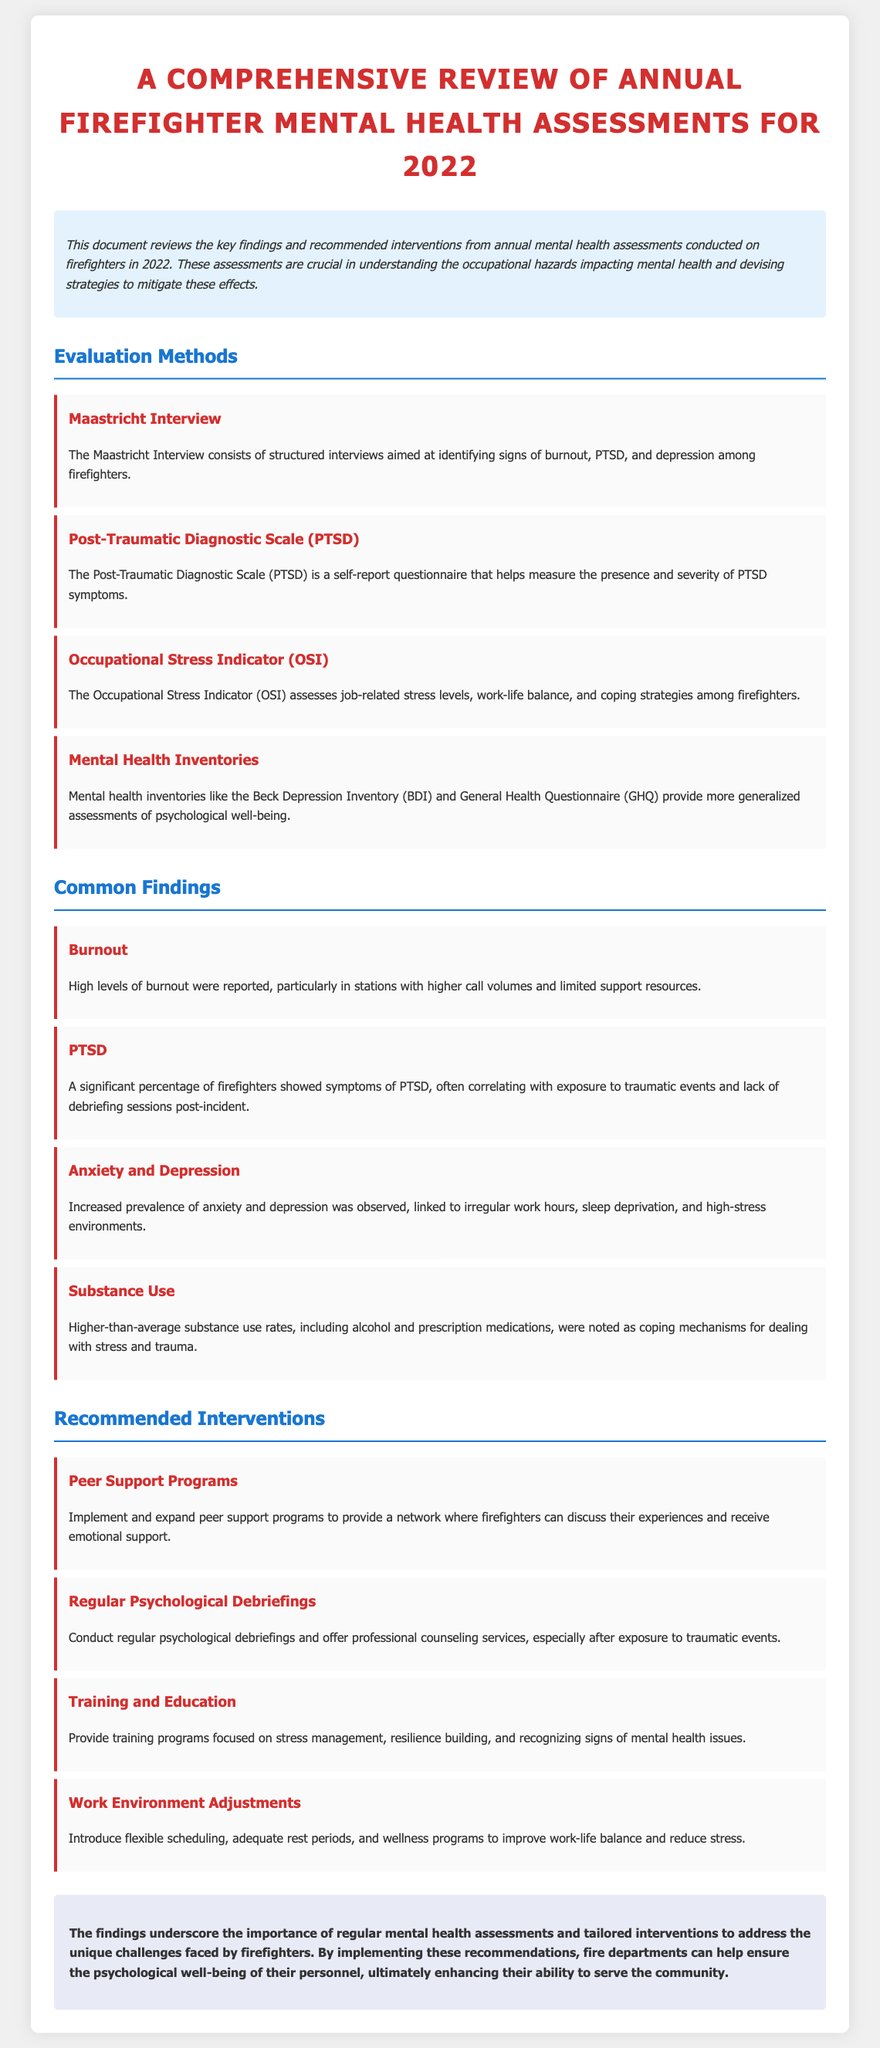What is the title of the document? The title of the document is clearly mentioned at the top and states the focus of the review.
Answer: A Comprehensive Review of Annual Firefighter Mental Health Assessments for 2022 What method is used to assess PTSD symptoms? The document specifies the name of the self-report questionnaire used to measure PTSD symptoms among firefighters.
Answer: Post-Traumatic Diagnostic Scale (PTSD) Which occupational stress indicator assesses work-life balance? The section on evaluation methods identifies the specific tool used to evaluate job-related stress levels, including work-life balance.
Answer: Occupational Stress Indicator (OSI) What is a common finding related to substance use? The document reveals a significant trend regarding coping mechanisms used by firefighters to deal with stress.
Answer: Higher-than-average substance use rates What intervention is recommended for peer support? The recommendations section outlines specific programs aimed at providing emotional support among firefighters.
Answer: Peer Support Programs How is burnout related to call volumes? The findings draw a connection between burnout levels and operational challenges within the firefighters' work environment.
Answer: Higher call volumes and limited support resources How many assessment methods are listed in the document? By counting the methods outlined under the evaluation methods section, the total can be determined.
Answer: Four What is a key conclusion of the review? The conclusion summarizes the importance of addressing mental health issues based on the findings from the assessments.
Answer: Regular mental health assessments and tailored interventions What does the document suggest for work environment adjustments? The document recommends specific changes to improve firefighters' work-life balance and reduce stress.
Answer: Flexible scheduling, adequate rest periods, and wellness programs 